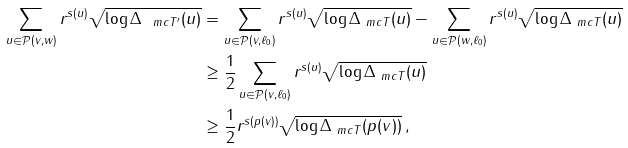<formula> <loc_0><loc_0><loc_500><loc_500>\sum _ { u \in \mathcal { P } ( v , w ) } r ^ { s ( u ) } \sqrt { \log \Delta _ { \ m c T ^ { \prime } } ( u ) } & = \sum _ { u \in \mathcal { P } ( v , \ell _ { 0 } ) } r ^ { s ( u ) } \sqrt { \log \Delta _ { \ m c T } ( u ) } - \sum _ { u \in \mathcal { P } ( w , \ell _ { 0 } ) } r ^ { s ( u ) } \sqrt { \log \Delta _ { \ m c T } ( u ) } \\ & \geq \frac { 1 } { 2 } \sum _ { u \in \mathcal { P } ( v , \ell _ { 0 } ) } r ^ { s ( u ) } \sqrt { \log \Delta _ { \ m c T } ( u ) } \\ & \geq \frac { 1 } { 2 } r ^ { s ( p ( v ) ) } \sqrt { \log \Delta _ { \ m c T } ( p ( v ) ) } \, ,</formula> 